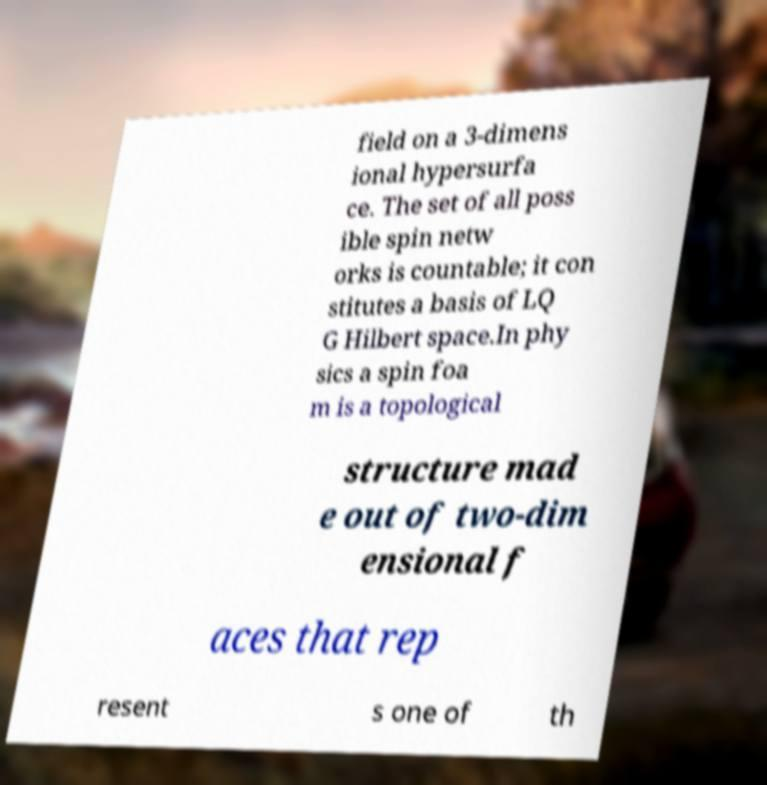I need the written content from this picture converted into text. Can you do that? field on a 3-dimens ional hypersurfa ce. The set of all poss ible spin netw orks is countable; it con stitutes a basis of LQ G Hilbert space.In phy sics a spin foa m is a topological structure mad e out of two-dim ensional f aces that rep resent s one of th 